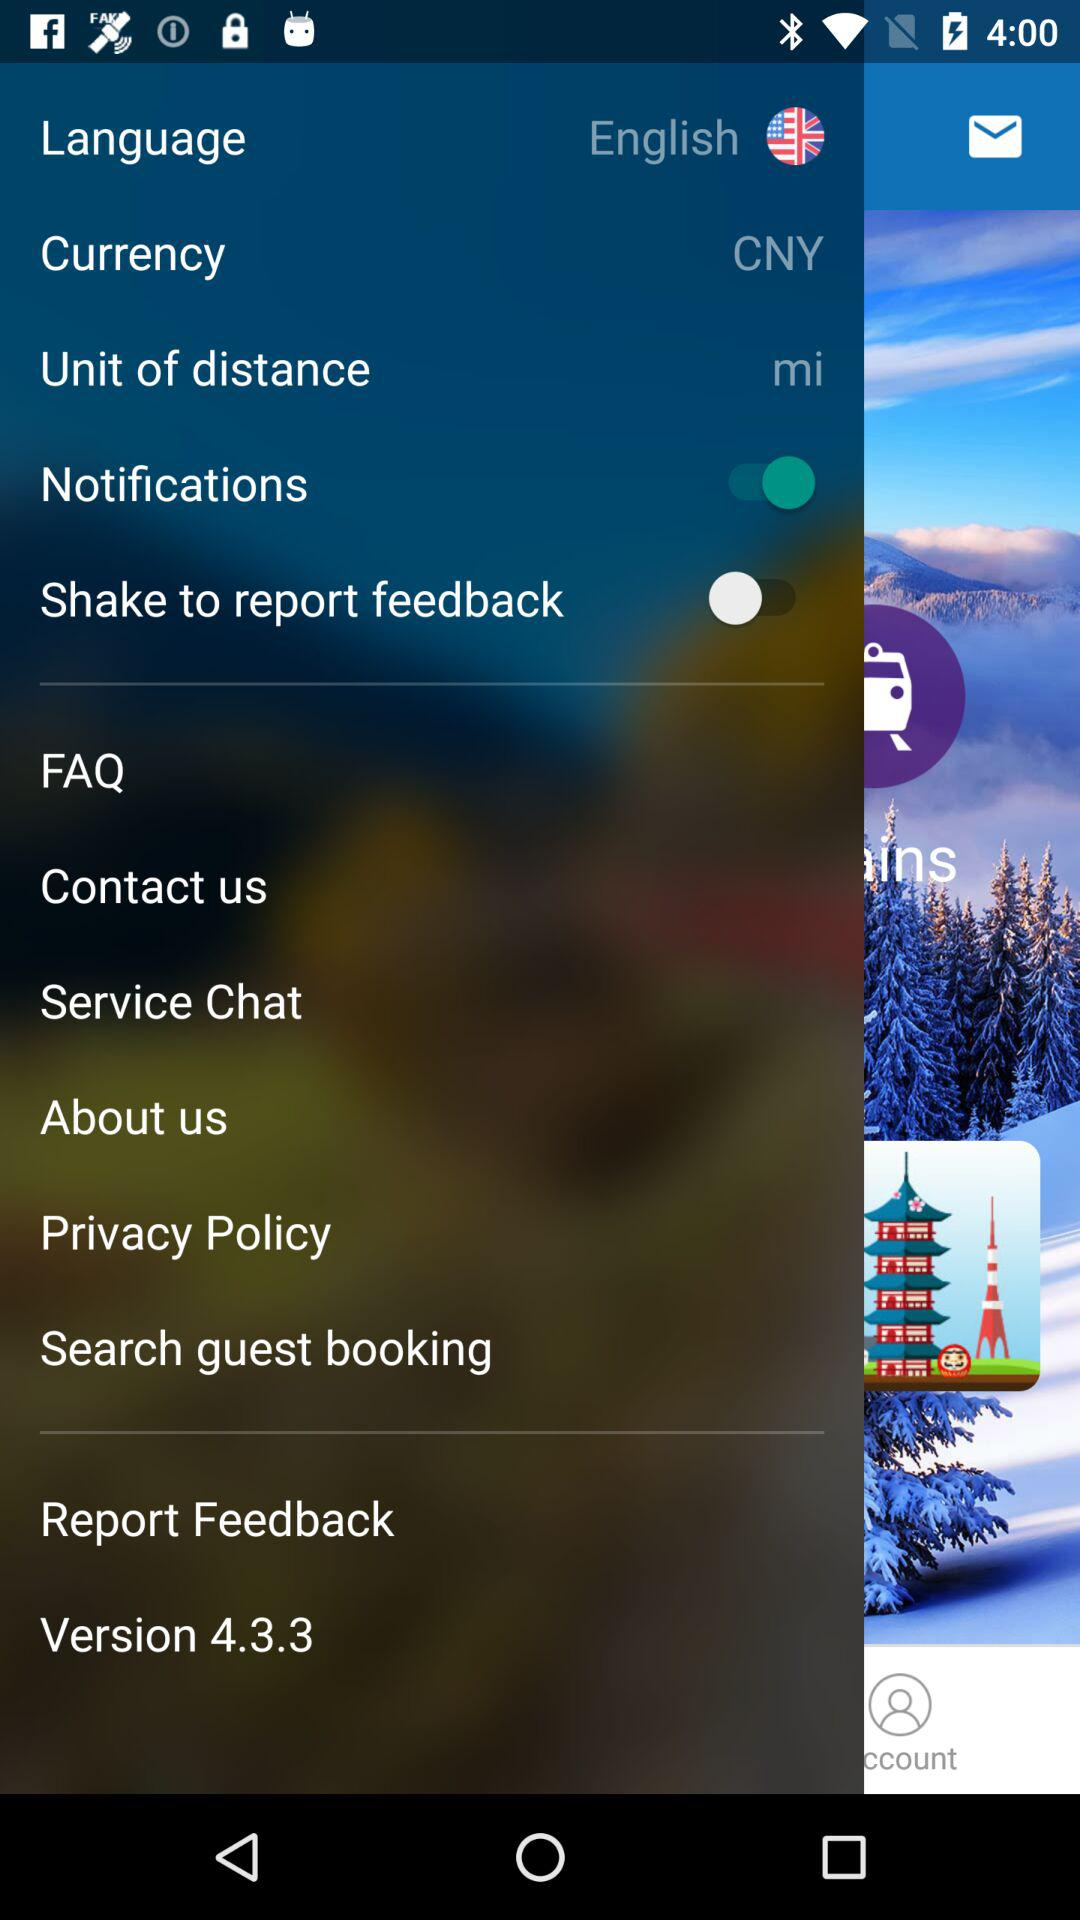What is the currency? The currency is the Chinese yuan. 